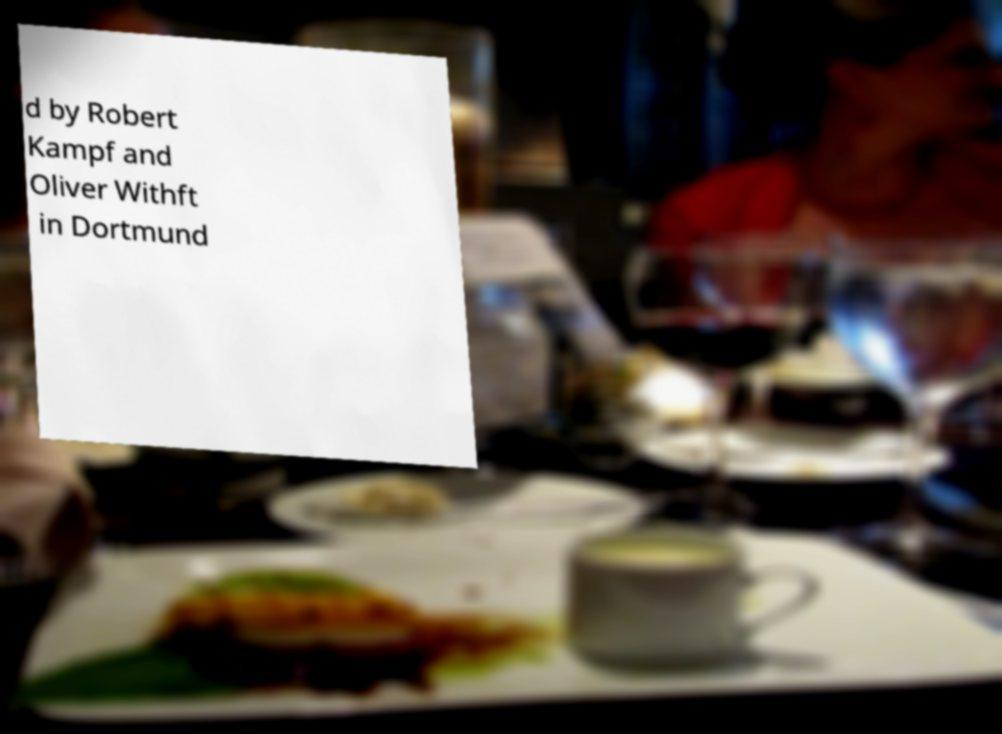What messages or text are displayed in this image? I need them in a readable, typed format. d by Robert Kampf and Oliver Withft in Dortmund 